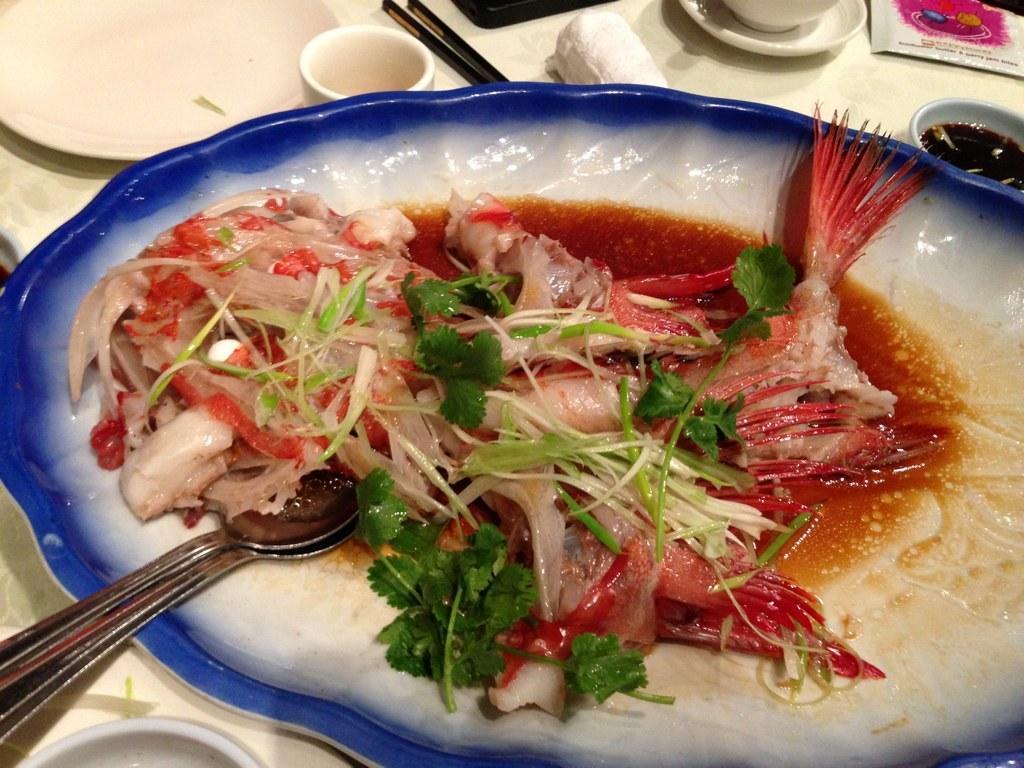Can you describe this image briefly? As we can see in the image there is a table. On table there are plates, cup, saucer, chopsticks and spoon. In plate there is a dish. 